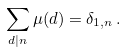<formula> <loc_0><loc_0><loc_500><loc_500>\sum _ { d | n } \mu ( d ) = \delta _ { 1 , n } \, .</formula> 